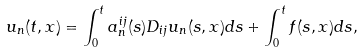Convert formula to latex. <formula><loc_0><loc_0><loc_500><loc_500>u _ { n } ( t , x ) = \int _ { 0 } ^ { t } a ^ { i j } _ { n } ( s ) D _ { i j } u _ { n } ( s , x ) d s + \int _ { 0 } ^ { t } f ( s , x ) d s ,</formula> 